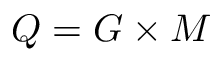Convert formula to latex. <formula><loc_0><loc_0><loc_500><loc_500>Q = G \times M</formula> 